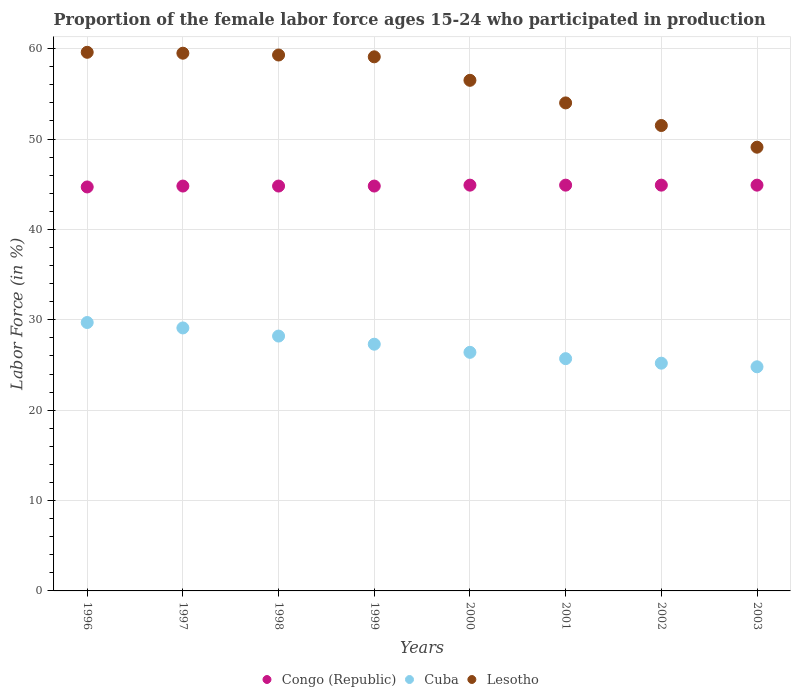How many different coloured dotlines are there?
Give a very brief answer. 3. Is the number of dotlines equal to the number of legend labels?
Your response must be concise. Yes. What is the proportion of the female labor force who participated in production in Lesotho in 2000?
Provide a short and direct response. 56.5. Across all years, what is the maximum proportion of the female labor force who participated in production in Lesotho?
Offer a terse response. 59.6. Across all years, what is the minimum proportion of the female labor force who participated in production in Congo (Republic)?
Ensure brevity in your answer.  44.7. In which year was the proportion of the female labor force who participated in production in Lesotho minimum?
Your response must be concise. 2003. What is the total proportion of the female labor force who participated in production in Cuba in the graph?
Offer a very short reply. 216.4. What is the difference between the proportion of the female labor force who participated in production in Congo (Republic) in 1999 and that in 2002?
Your response must be concise. -0.1. What is the difference between the proportion of the female labor force who participated in production in Congo (Republic) in 1998 and the proportion of the female labor force who participated in production in Cuba in 2002?
Offer a terse response. 19.6. What is the average proportion of the female labor force who participated in production in Cuba per year?
Your answer should be very brief. 27.05. In the year 2003, what is the difference between the proportion of the female labor force who participated in production in Congo (Republic) and proportion of the female labor force who participated in production in Lesotho?
Provide a succinct answer. -4.2. In how many years, is the proportion of the female labor force who participated in production in Cuba greater than 18 %?
Provide a succinct answer. 8. Is the difference between the proportion of the female labor force who participated in production in Congo (Republic) in 2000 and 2002 greater than the difference between the proportion of the female labor force who participated in production in Lesotho in 2000 and 2002?
Provide a short and direct response. No. What is the difference between the highest and the second highest proportion of the female labor force who participated in production in Lesotho?
Your response must be concise. 0.1. What is the difference between the highest and the lowest proportion of the female labor force who participated in production in Cuba?
Make the answer very short. 4.9. Is the proportion of the female labor force who participated in production in Lesotho strictly greater than the proportion of the female labor force who participated in production in Congo (Republic) over the years?
Make the answer very short. Yes. Are the values on the major ticks of Y-axis written in scientific E-notation?
Make the answer very short. No. Where does the legend appear in the graph?
Make the answer very short. Bottom center. What is the title of the graph?
Make the answer very short. Proportion of the female labor force ages 15-24 who participated in production. What is the Labor Force (in %) in Congo (Republic) in 1996?
Provide a succinct answer. 44.7. What is the Labor Force (in %) in Cuba in 1996?
Give a very brief answer. 29.7. What is the Labor Force (in %) in Lesotho in 1996?
Your response must be concise. 59.6. What is the Labor Force (in %) of Congo (Republic) in 1997?
Make the answer very short. 44.8. What is the Labor Force (in %) of Cuba in 1997?
Your answer should be compact. 29.1. What is the Labor Force (in %) in Lesotho in 1997?
Ensure brevity in your answer.  59.5. What is the Labor Force (in %) in Congo (Republic) in 1998?
Your response must be concise. 44.8. What is the Labor Force (in %) in Cuba in 1998?
Make the answer very short. 28.2. What is the Labor Force (in %) of Lesotho in 1998?
Your response must be concise. 59.3. What is the Labor Force (in %) of Congo (Republic) in 1999?
Provide a succinct answer. 44.8. What is the Labor Force (in %) in Cuba in 1999?
Your answer should be compact. 27.3. What is the Labor Force (in %) of Lesotho in 1999?
Your answer should be compact. 59.1. What is the Labor Force (in %) in Congo (Republic) in 2000?
Keep it short and to the point. 44.9. What is the Labor Force (in %) in Cuba in 2000?
Provide a succinct answer. 26.4. What is the Labor Force (in %) in Lesotho in 2000?
Ensure brevity in your answer.  56.5. What is the Labor Force (in %) of Congo (Republic) in 2001?
Provide a succinct answer. 44.9. What is the Labor Force (in %) of Cuba in 2001?
Ensure brevity in your answer.  25.7. What is the Labor Force (in %) in Lesotho in 2001?
Your answer should be very brief. 54. What is the Labor Force (in %) of Congo (Republic) in 2002?
Your answer should be very brief. 44.9. What is the Labor Force (in %) in Cuba in 2002?
Provide a short and direct response. 25.2. What is the Labor Force (in %) of Lesotho in 2002?
Provide a succinct answer. 51.5. What is the Labor Force (in %) in Congo (Republic) in 2003?
Offer a very short reply. 44.9. What is the Labor Force (in %) of Cuba in 2003?
Offer a terse response. 24.8. What is the Labor Force (in %) of Lesotho in 2003?
Keep it short and to the point. 49.1. Across all years, what is the maximum Labor Force (in %) in Congo (Republic)?
Give a very brief answer. 44.9. Across all years, what is the maximum Labor Force (in %) in Cuba?
Provide a short and direct response. 29.7. Across all years, what is the maximum Labor Force (in %) of Lesotho?
Make the answer very short. 59.6. Across all years, what is the minimum Labor Force (in %) of Congo (Republic)?
Offer a terse response. 44.7. Across all years, what is the minimum Labor Force (in %) of Cuba?
Keep it short and to the point. 24.8. Across all years, what is the minimum Labor Force (in %) in Lesotho?
Offer a terse response. 49.1. What is the total Labor Force (in %) of Congo (Republic) in the graph?
Your answer should be compact. 358.7. What is the total Labor Force (in %) of Cuba in the graph?
Your answer should be compact. 216.4. What is the total Labor Force (in %) of Lesotho in the graph?
Offer a very short reply. 448.6. What is the difference between the Labor Force (in %) of Congo (Republic) in 1996 and that in 1997?
Your response must be concise. -0.1. What is the difference between the Labor Force (in %) in Cuba in 1996 and that in 1997?
Keep it short and to the point. 0.6. What is the difference between the Labor Force (in %) in Congo (Republic) in 1996 and that in 1998?
Your answer should be very brief. -0.1. What is the difference between the Labor Force (in %) in Cuba in 1996 and that in 1998?
Give a very brief answer. 1.5. What is the difference between the Labor Force (in %) in Lesotho in 1996 and that in 1998?
Ensure brevity in your answer.  0.3. What is the difference between the Labor Force (in %) in Cuba in 1996 and that in 1999?
Your answer should be compact. 2.4. What is the difference between the Labor Force (in %) of Congo (Republic) in 1996 and that in 2000?
Ensure brevity in your answer.  -0.2. What is the difference between the Labor Force (in %) in Lesotho in 1996 and that in 2000?
Give a very brief answer. 3.1. What is the difference between the Labor Force (in %) in Congo (Republic) in 1996 and that in 2001?
Your answer should be very brief. -0.2. What is the difference between the Labor Force (in %) of Cuba in 1996 and that in 2001?
Offer a very short reply. 4. What is the difference between the Labor Force (in %) in Cuba in 1996 and that in 2003?
Provide a succinct answer. 4.9. What is the difference between the Labor Force (in %) in Lesotho in 1996 and that in 2003?
Ensure brevity in your answer.  10.5. What is the difference between the Labor Force (in %) of Congo (Republic) in 1997 and that in 1998?
Ensure brevity in your answer.  0. What is the difference between the Labor Force (in %) in Cuba in 1997 and that in 1998?
Keep it short and to the point. 0.9. What is the difference between the Labor Force (in %) of Congo (Republic) in 1997 and that in 1999?
Your answer should be compact. 0. What is the difference between the Labor Force (in %) of Lesotho in 1997 and that in 2000?
Your response must be concise. 3. What is the difference between the Labor Force (in %) of Congo (Republic) in 1997 and that in 2001?
Keep it short and to the point. -0.1. What is the difference between the Labor Force (in %) of Cuba in 1997 and that in 2001?
Provide a short and direct response. 3.4. What is the difference between the Labor Force (in %) of Lesotho in 1997 and that in 2002?
Offer a very short reply. 8. What is the difference between the Labor Force (in %) in Congo (Republic) in 1997 and that in 2003?
Your answer should be compact. -0.1. What is the difference between the Labor Force (in %) of Lesotho in 1997 and that in 2003?
Offer a terse response. 10.4. What is the difference between the Labor Force (in %) in Congo (Republic) in 1998 and that in 2000?
Give a very brief answer. -0.1. What is the difference between the Labor Force (in %) in Cuba in 1998 and that in 2000?
Make the answer very short. 1.8. What is the difference between the Labor Force (in %) in Lesotho in 1998 and that in 2000?
Provide a succinct answer. 2.8. What is the difference between the Labor Force (in %) in Congo (Republic) in 1998 and that in 2001?
Ensure brevity in your answer.  -0.1. What is the difference between the Labor Force (in %) of Lesotho in 1998 and that in 2001?
Make the answer very short. 5.3. What is the difference between the Labor Force (in %) of Cuba in 1998 and that in 2002?
Keep it short and to the point. 3. What is the difference between the Labor Force (in %) of Lesotho in 1998 and that in 2002?
Keep it short and to the point. 7.8. What is the difference between the Labor Force (in %) in Congo (Republic) in 1999 and that in 2003?
Provide a short and direct response. -0.1. What is the difference between the Labor Force (in %) in Congo (Republic) in 2000 and that in 2001?
Offer a terse response. 0. What is the difference between the Labor Force (in %) of Cuba in 2000 and that in 2001?
Your response must be concise. 0.7. What is the difference between the Labor Force (in %) in Congo (Republic) in 2000 and that in 2002?
Give a very brief answer. 0. What is the difference between the Labor Force (in %) of Lesotho in 2000 and that in 2002?
Give a very brief answer. 5. What is the difference between the Labor Force (in %) in Congo (Republic) in 2000 and that in 2003?
Your answer should be compact. 0. What is the difference between the Labor Force (in %) of Cuba in 2000 and that in 2003?
Keep it short and to the point. 1.6. What is the difference between the Labor Force (in %) of Lesotho in 2000 and that in 2003?
Your answer should be very brief. 7.4. What is the difference between the Labor Force (in %) in Congo (Republic) in 2001 and that in 2002?
Provide a succinct answer. 0. What is the difference between the Labor Force (in %) in Cuba in 2001 and that in 2003?
Offer a very short reply. 0.9. What is the difference between the Labor Force (in %) in Congo (Republic) in 2002 and that in 2003?
Provide a succinct answer. 0. What is the difference between the Labor Force (in %) in Lesotho in 2002 and that in 2003?
Give a very brief answer. 2.4. What is the difference between the Labor Force (in %) in Congo (Republic) in 1996 and the Labor Force (in %) in Cuba in 1997?
Keep it short and to the point. 15.6. What is the difference between the Labor Force (in %) in Congo (Republic) in 1996 and the Labor Force (in %) in Lesotho in 1997?
Your answer should be compact. -14.8. What is the difference between the Labor Force (in %) in Cuba in 1996 and the Labor Force (in %) in Lesotho in 1997?
Offer a very short reply. -29.8. What is the difference between the Labor Force (in %) in Congo (Republic) in 1996 and the Labor Force (in %) in Cuba in 1998?
Your answer should be compact. 16.5. What is the difference between the Labor Force (in %) in Congo (Republic) in 1996 and the Labor Force (in %) in Lesotho in 1998?
Provide a succinct answer. -14.6. What is the difference between the Labor Force (in %) of Cuba in 1996 and the Labor Force (in %) of Lesotho in 1998?
Offer a terse response. -29.6. What is the difference between the Labor Force (in %) in Congo (Republic) in 1996 and the Labor Force (in %) in Lesotho in 1999?
Offer a very short reply. -14.4. What is the difference between the Labor Force (in %) in Cuba in 1996 and the Labor Force (in %) in Lesotho in 1999?
Provide a succinct answer. -29.4. What is the difference between the Labor Force (in %) in Cuba in 1996 and the Labor Force (in %) in Lesotho in 2000?
Provide a short and direct response. -26.8. What is the difference between the Labor Force (in %) of Cuba in 1996 and the Labor Force (in %) of Lesotho in 2001?
Your response must be concise. -24.3. What is the difference between the Labor Force (in %) in Congo (Republic) in 1996 and the Labor Force (in %) in Cuba in 2002?
Provide a short and direct response. 19.5. What is the difference between the Labor Force (in %) in Cuba in 1996 and the Labor Force (in %) in Lesotho in 2002?
Make the answer very short. -21.8. What is the difference between the Labor Force (in %) in Congo (Republic) in 1996 and the Labor Force (in %) in Lesotho in 2003?
Provide a short and direct response. -4.4. What is the difference between the Labor Force (in %) of Cuba in 1996 and the Labor Force (in %) of Lesotho in 2003?
Offer a very short reply. -19.4. What is the difference between the Labor Force (in %) of Congo (Republic) in 1997 and the Labor Force (in %) of Lesotho in 1998?
Provide a succinct answer. -14.5. What is the difference between the Labor Force (in %) in Cuba in 1997 and the Labor Force (in %) in Lesotho in 1998?
Your answer should be very brief. -30.2. What is the difference between the Labor Force (in %) of Congo (Republic) in 1997 and the Labor Force (in %) of Cuba in 1999?
Ensure brevity in your answer.  17.5. What is the difference between the Labor Force (in %) in Congo (Republic) in 1997 and the Labor Force (in %) in Lesotho in 1999?
Provide a short and direct response. -14.3. What is the difference between the Labor Force (in %) of Cuba in 1997 and the Labor Force (in %) of Lesotho in 2000?
Keep it short and to the point. -27.4. What is the difference between the Labor Force (in %) of Cuba in 1997 and the Labor Force (in %) of Lesotho in 2001?
Your answer should be compact. -24.9. What is the difference between the Labor Force (in %) of Congo (Republic) in 1997 and the Labor Force (in %) of Cuba in 2002?
Your answer should be compact. 19.6. What is the difference between the Labor Force (in %) of Cuba in 1997 and the Labor Force (in %) of Lesotho in 2002?
Your answer should be compact. -22.4. What is the difference between the Labor Force (in %) of Congo (Republic) in 1997 and the Labor Force (in %) of Lesotho in 2003?
Offer a terse response. -4.3. What is the difference between the Labor Force (in %) in Congo (Republic) in 1998 and the Labor Force (in %) in Cuba in 1999?
Provide a succinct answer. 17.5. What is the difference between the Labor Force (in %) of Congo (Republic) in 1998 and the Labor Force (in %) of Lesotho in 1999?
Keep it short and to the point. -14.3. What is the difference between the Labor Force (in %) in Cuba in 1998 and the Labor Force (in %) in Lesotho in 1999?
Keep it short and to the point. -30.9. What is the difference between the Labor Force (in %) of Congo (Republic) in 1998 and the Labor Force (in %) of Lesotho in 2000?
Give a very brief answer. -11.7. What is the difference between the Labor Force (in %) in Cuba in 1998 and the Labor Force (in %) in Lesotho in 2000?
Your response must be concise. -28.3. What is the difference between the Labor Force (in %) in Congo (Republic) in 1998 and the Labor Force (in %) in Cuba in 2001?
Ensure brevity in your answer.  19.1. What is the difference between the Labor Force (in %) of Cuba in 1998 and the Labor Force (in %) of Lesotho in 2001?
Offer a very short reply. -25.8. What is the difference between the Labor Force (in %) of Congo (Republic) in 1998 and the Labor Force (in %) of Cuba in 2002?
Make the answer very short. 19.6. What is the difference between the Labor Force (in %) in Congo (Republic) in 1998 and the Labor Force (in %) in Lesotho in 2002?
Offer a terse response. -6.7. What is the difference between the Labor Force (in %) of Cuba in 1998 and the Labor Force (in %) of Lesotho in 2002?
Your answer should be very brief. -23.3. What is the difference between the Labor Force (in %) of Congo (Republic) in 1998 and the Labor Force (in %) of Lesotho in 2003?
Your answer should be very brief. -4.3. What is the difference between the Labor Force (in %) of Cuba in 1998 and the Labor Force (in %) of Lesotho in 2003?
Keep it short and to the point. -20.9. What is the difference between the Labor Force (in %) in Congo (Republic) in 1999 and the Labor Force (in %) in Lesotho in 2000?
Offer a terse response. -11.7. What is the difference between the Labor Force (in %) of Cuba in 1999 and the Labor Force (in %) of Lesotho in 2000?
Keep it short and to the point. -29.2. What is the difference between the Labor Force (in %) in Congo (Republic) in 1999 and the Labor Force (in %) in Cuba in 2001?
Give a very brief answer. 19.1. What is the difference between the Labor Force (in %) of Cuba in 1999 and the Labor Force (in %) of Lesotho in 2001?
Your response must be concise. -26.7. What is the difference between the Labor Force (in %) in Congo (Republic) in 1999 and the Labor Force (in %) in Cuba in 2002?
Keep it short and to the point. 19.6. What is the difference between the Labor Force (in %) in Congo (Republic) in 1999 and the Labor Force (in %) in Lesotho in 2002?
Your answer should be compact. -6.7. What is the difference between the Labor Force (in %) of Cuba in 1999 and the Labor Force (in %) of Lesotho in 2002?
Make the answer very short. -24.2. What is the difference between the Labor Force (in %) in Congo (Republic) in 1999 and the Labor Force (in %) in Cuba in 2003?
Keep it short and to the point. 20. What is the difference between the Labor Force (in %) in Cuba in 1999 and the Labor Force (in %) in Lesotho in 2003?
Give a very brief answer. -21.8. What is the difference between the Labor Force (in %) of Congo (Republic) in 2000 and the Labor Force (in %) of Cuba in 2001?
Your answer should be very brief. 19.2. What is the difference between the Labor Force (in %) of Cuba in 2000 and the Labor Force (in %) of Lesotho in 2001?
Your answer should be compact. -27.6. What is the difference between the Labor Force (in %) in Congo (Republic) in 2000 and the Labor Force (in %) in Lesotho in 2002?
Keep it short and to the point. -6.6. What is the difference between the Labor Force (in %) in Cuba in 2000 and the Labor Force (in %) in Lesotho in 2002?
Provide a short and direct response. -25.1. What is the difference between the Labor Force (in %) of Congo (Republic) in 2000 and the Labor Force (in %) of Cuba in 2003?
Provide a succinct answer. 20.1. What is the difference between the Labor Force (in %) of Cuba in 2000 and the Labor Force (in %) of Lesotho in 2003?
Keep it short and to the point. -22.7. What is the difference between the Labor Force (in %) in Congo (Republic) in 2001 and the Labor Force (in %) in Cuba in 2002?
Make the answer very short. 19.7. What is the difference between the Labor Force (in %) of Congo (Republic) in 2001 and the Labor Force (in %) of Lesotho in 2002?
Provide a short and direct response. -6.6. What is the difference between the Labor Force (in %) of Cuba in 2001 and the Labor Force (in %) of Lesotho in 2002?
Ensure brevity in your answer.  -25.8. What is the difference between the Labor Force (in %) in Congo (Republic) in 2001 and the Labor Force (in %) in Cuba in 2003?
Keep it short and to the point. 20.1. What is the difference between the Labor Force (in %) in Congo (Republic) in 2001 and the Labor Force (in %) in Lesotho in 2003?
Give a very brief answer. -4.2. What is the difference between the Labor Force (in %) of Cuba in 2001 and the Labor Force (in %) of Lesotho in 2003?
Offer a terse response. -23.4. What is the difference between the Labor Force (in %) in Congo (Republic) in 2002 and the Labor Force (in %) in Cuba in 2003?
Offer a very short reply. 20.1. What is the difference between the Labor Force (in %) in Congo (Republic) in 2002 and the Labor Force (in %) in Lesotho in 2003?
Keep it short and to the point. -4.2. What is the difference between the Labor Force (in %) in Cuba in 2002 and the Labor Force (in %) in Lesotho in 2003?
Keep it short and to the point. -23.9. What is the average Labor Force (in %) in Congo (Republic) per year?
Provide a short and direct response. 44.84. What is the average Labor Force (in %) of Cuba per year?
Your response must be concise. 27.05. What is the average Labor Force (in %) of Lesotho per year?
Ensure brevity in your answer.  56.08. In the year 1996, what is the difference between the Labor Force (in %) in Congo (Republic) and Labor Force (in %) in Lesotho?
Offer a terse response. -14.9. In the year 1996, what is the difference between the Labor Force (in %) of Cuba and Labor Force (in %) of Lesotho?
Ensure brevity in your answer.  -29.9. In the year 1997, what is the difference between the Labor Force (in %) in Congo (Republic) and Labor Force (in %) in Cuba?
Ensure brevity in your answer.  15.7. In the year 1997, what is the difference between the Labor Force (in %) in Congo (Republic) and Labor Force (in %) in Lesotho?
Offer a very short reply. -14.7. In the year 1997, what is the difference between the Labor Force (in %) in Cuba and Labor Force (in %) in Lesotho?
Make the answer very short. -30.4. In the year 1998, what is the difference between the Labor Force (in %) of Congo (Republic) and Labor Force (in %) of Cuba?
Offer a very short reply. 16.6. In the year 1998, what is the difference between the Labor Force (in %) in Congo (Republic) and Labor Force (in %) in Lesotho?
Provide a succinct answer. -14.5. In the year 1998, what is the difference between the Labor Force (in %) of Cuba and Labor Force (in %) of Lesotho?
Give a very brief answer. -31.1. In the year 1999, what is the difference between the Labor Force (in %) of Congo (Republic) and Labor Force (in %) of Cuba?
Give a very brief answer. 17.5. In the year 1999, what is the difference between the Labor Force (in %) in Congo (Republic) and Labor Force (in %) in Lesotho?
Offer a very short reply. -14.3. In the year 1999, what is the difference between the Labor Force (in %) in Cuba and Labor Force (in %) in Lesotho?
Keep it short and to the point. -31.8. In the year 2000, what is the difference between the Labor Force (in %) of Congo (Republic) and Labor Force (in %) of Cuba?
Provide a short and direct response. 18.5. In the year 2000, what is the difference between the Labor Force (in %) in Cuba and Labor Force (in %) in Lesotho?
Provide a short and direct response. -30.1. In the year 2001, what is the difference between the Labor Force (in %) in Congo (Republic) and Labor Force (in %) in Cuba?
Offer a terse response. 19.2. In the year 2001, what is the difference between the Labor Force (in %) in Cuba and Labor Force (in %) in Lesotho?
Your answer should be very brief. -28.3. In the year 2002, what is the difference between the Labor Force (in %) in Congo (Republic) and Labor Force (in %) in Cuba?
Provide a short and direct response. 19.7. In the year 2002, what is the difference between the Labor Force (in %) in Congo (Republic) and Labor Force (in %) in Lesotho?
Keep it short and to the point. -6.6. In the year 2002, what is the difference between the Labor Force (in %) of Cuba and Labor Force (in %) of Lesotho?
Your answer should be very brief. -26.3. In the year 2003, what is the difference between the Labor Force (in %) of Congo (Republic) and Labor Force (in %) of Cuba?
Offer a very short reply. 20.1. In the year 2003, what is the difference between the Labor Force (in %) of Cuba and Labor Force (in %) of Lesotho?
Give a very brief answer. -24.3. What is the ratio of the Labor Force (in %) of Congo (Republic) in 1996 to that in 1997?
Provide a short and direct response. 1. What is the ratio of the Labor Force (in %) of Cuba in 1996 to that in 1997?
Ensure brevity in your answer.  1.02. What is the ratio of the Labor Force (in %) of Lesotho in 1996 to that in 1997?
Your response must be concise. 1. What is the ratio of the Labor Force (in %) of Congo (Republic) in 1996 to that in 1998?
Provide a succinct answer. 1. What is the ratio of the Labor Force (in %) in Cuba in 1996 to that in 1998?
Keep it short and to the point. 1.05. What is the ratio of the Labor Force (in %) in Cuba in 1996 to that in 1999?
Offer a very short reply. 1.09. What is the ratio of the Labor Force (in %) in Lesotho in 1996 to that in 1999?
Provide a short and direct response. 1.01. What is the ratio of the Labor Force (in %) of Lesotho in 1996 to that in 2000?
Offer a very short reply. 1.05. What is the ratio of the Labor Force (in %) in Congo (Republic) in 1996 to that in 2001?
Offer a very short reply. 1. What is the ratio of the Labor Force (in %) in Cuba in 1996 to that in 2001?
Ensure brevity in your answer.  1.16. What is the ratio of the Labor Force (in %) in Lesotho in 1996 to that in 2001?
Your answer should be very brief. 1.1. What is the ratio of the Labor Force (in %) in Congo (Republic) in 1996 to that in 2002?
Ensure brevity in your answer.  1. What is the ratio of the Labor Force (in %) in Cuba in 1996 to that in 2002?
Your response must be concise. 1.18. What is the ratio of the Labor Force (in %) in Lesotho in 1996 to that in 2002?
Offer a terse response. 1.16. What is the ratio of the Labor Force (in %) in Congo (Republic) in 1996 to that in 2003?
Your answer should be very brief. 1. What is the ratio of the Labor Force (in %) of Cuba in 1996 to that in 2003?
Provide a short and direct response. 1.2. What is the ratio of the Labor Force (in %) in Lesotho in 1996 to that in 2003?
Make the answer very short. 1.21. What is the ratio of the Labor Force (in %) of Congo (Republic) in 1997 to that in 1998?
Your response must be concise. 1. What is the ratio of the Labor Force (in %) in Cuba in 1997 to that in 1998?
Offer a terse response. 1.03. What is the ratio of the Labor Force (in %) of Cuba in 1997 to that in 1999?
Ensure brevity in your answer.  1.07. What is the ratio of the Labor Force (in %) in Lesotho in 1997 to that in 1999?
Offer a terse response. 1.01. What is the ratio of the Labor Force (in %) in Cuba in 1997 to that in 2000?
Keep it short and to the point. 1.1. What is the ratio of the Labor Force (in %) of Lesotho in 1997 to that in 2000?
Offer a terse response. 1.05. What is the ratio of the Labor Force (in %) in Cuba in 1997 to that in 2001?
Your answer should be compact. 1.13. What is the ratio of the Labor Force (in %) of Lesotho in 1997 to that in 2001?
Your response must be concise. 1.1. What is the ratio of the Labor Force (in %) of Cuba in 1997 to that in 2002?
Your response must be concise. 1.15. What is the ratio of the Labor Force (in %) in Lesotho in 1997 to that in 2002?
Keep it short and to the point. 1.16. What is the ratio of the Labor Force (in %) in Cuba in 1997 to that in 2003?
Keep it short and to the point. 1.17. What is the ratio of the Labor Force (in %) in Lesotho in 1997 to that in 2003?
Provide a succinct answer. 1.21. What is the ratio of the Labor Force (in %) of Congo (Republic) in 1998 to that in 1999?
Your answer should be compact. 1. What is the ratio of the Labor Force (in %) of Cuba in 1998 to that in 1999?
Ensure brevity in your answer.  1.03. What is the ratio of the Labor Force (in %) of Cuba in 1998 to that in 2000?
Offer a very short reply. 1.07. What is the ratio of the Labor Force (in %) in Lesotho in 1998 to that in 2000?
Offer a very short reply. 1.05. What is the ratio of the Labor Force (in %) in Cuba in 1998 to that in 2001?
Your answer should be very brief. 1.1. What is the ratio of the Labor Force (in %) in Lesotho in 1998 to that in 2001?
Your answer should be very brief. 1.1. What is the ratio of the Labor Force (in %) of Cuba in 1998 to that in 2002?
Provide a short and direct response. 1.12. What is the ratio of the Labor Force (in %) of Lesotho in 1998 to that in 2002?
Offer a very short reply. 1.15. What is the ratio of the Labor Force (in %) of Cuba in 1998 to that in 2003?
Ensure brevity in your answer.  1.14. What is the ratio of the Labor Force (in %) in Lesotho in 1998 to that in 2003?
Keep it short and to the point. 1.21. What is the ratio of the Labor Force (in %) of Congo (Republic) in 1999 to that in 2000?
Provide a succinct answer. 1. What is the ratio of the Labor Force (in %) in Cuba in 1999 to that in 2000?
Provide a short and direct response. 1.03. What is the ratio of the Labor Force (in %) in Lesotho in 1999 to that in 2000?
Your answer should be compact. 1.05. What is the ratio of the Labor Force (in %) in Congo (Republic) in 1999 to that in 2001?
Keep it short and to the point. 1. What is the ratio of the Labor Force (in %) in Cuba in 1999 to that in 2001?
Offer a very short reply. 1.06. What is the ratio of the Labor Force (in %) in Lesotho in 1999 to that in 2001?
Your answer should be very brief. 1.09. What is the ratio of the Labor Force (in %) of Congo (Republic) in 1999 to that in 2002?
Provide a short and direct response. 1. What is the ratio of the Labor Force (in %) of Cuba in 1999 to that in 2002?
Your answer should be compact. 1.08. What is the ratio of the Labor Force (in %) in Lesotho in 1999 to that in 2002?
Your answer should be very brief. 1.15. What is the ratio of the Labor Force (in %) of Congo (Republic) in 1999 to that in 2003?
Offer a terse response. 1. What is the ratio of the Labor Force (in %) of Cuba in 1999 to that in 2003?
Offer a terse response. 1.1. What is the ratio of the Labor Force (in %) in Lesotho in 1999 to that in 2003?
Provide a succinct answer. 1.2. What is the ratio of the Labor Force (in %) of Congo (Republic) in 2000 to that in 2001?
Provide a succinct answer. 1. What is the ratio of the Labor Force (in %) in Cuba in 2000 to that in 2001?
Make the answer very short. 1.03. What is the ratio of the Labor Force (in %) of Lesotho in 2000 to that in 2001?
Make the answer very short. 1.05. What is the ratio of the Labor Force (in %) in Cuba in 2000 to that in 2002?
Provide a succinct answer. 1.05. What is the ratio of the Labor Force (in %) in Lesotho in 2000 to that in 2002?
Give a very brief answer. 1.1. What is the ratio of the Labor Force (in %) of Congo (Republic) in 2000 to that in 2003?
Make the answer very short. 1. What is the ratio of the Labor Force (in %) of Cuba in 2000 to that in 2003?
Give a very brief answer. 1.06. What is the ratio of the Labor Force (in %) in Lesotho in 2000 to that in 2003?
Ensure brevity in your answer.  1.15. What is the ratio of the Labor Force (in %) in Congo (Republic) in 2001 to that in 2002?
Offer a very short reply. 1. What is the ratio of the Labor Force (in %) of Cuba in 2001 to that in 2002?
Provide a short and direct response. 1.02. What is the ratio of the Labor Force (in %) in Lesotho in 2001 to that in 2002?
Keep it short and to the point. 1.05. What is the ratio of the Labor Force (in %) in Cuba in 2001 to that in 2003?
Give a very brief answer. 1.04. What is the ratio of the Labor Force (in %) in Lesotho in 2001 to that in 2003?
Your response must be concise. 1.1. What is the ratio of the Labor Force (in %) in Congo (Republic) in 2002 to that in 2003?
Ensure brevity in your answer.  1. What is the ratio of the Labor Force (in %) in Cuba in 2002 to that in 2003?
Ensure brevity in your answer.  1.02. What is the ratio of the Labor Force (in %) of Lesotho in 2002 to that in 2003?
Your answer should be very brief. 1.05. What is the difference between the highest and the second highest Labor Force (in %) in Cuba?
Ensure brevity in your answer.  0.6. What is the difference between the highest and the second highest Labor Force (in %) in Lesotho?
Keep it short and to the point. 0.1. What is the difference between the highest and the lowest Labor Force (in %) of Cuba?
Ensure brevity in your answer.  4.9. What is the difference between the highest and the lowest Labor Force (in %) in Lesotho?
Your response must be concise. 10.5. 